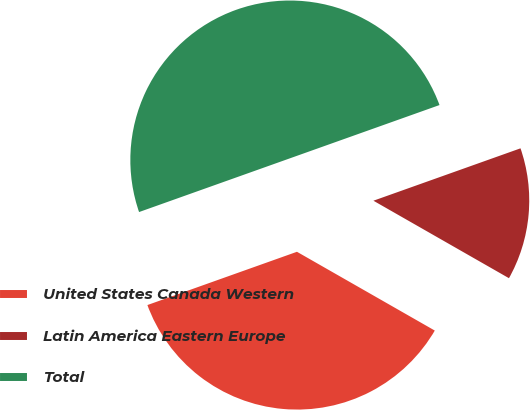Convert chart to OTSL. <chart><loc_0><loc_0><loc_500><loc_500><pie_chart><fcel>United States Canada Western<fcel>Latin America Eastern Europe<fcel>Total<nl><fcel>36.29%<fcel>13.71%<fcel>50.0%<nl></chart> 